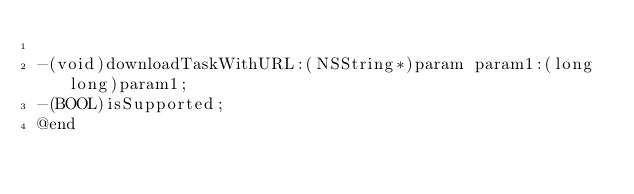<code> <loc_0><loc_0><loc_500><loc_500><_C_>
-(void)downloadTaskWithURL:(NSString*)param param1:(long long)param1;
-(BOOL)isSupported;
@end
</code> 